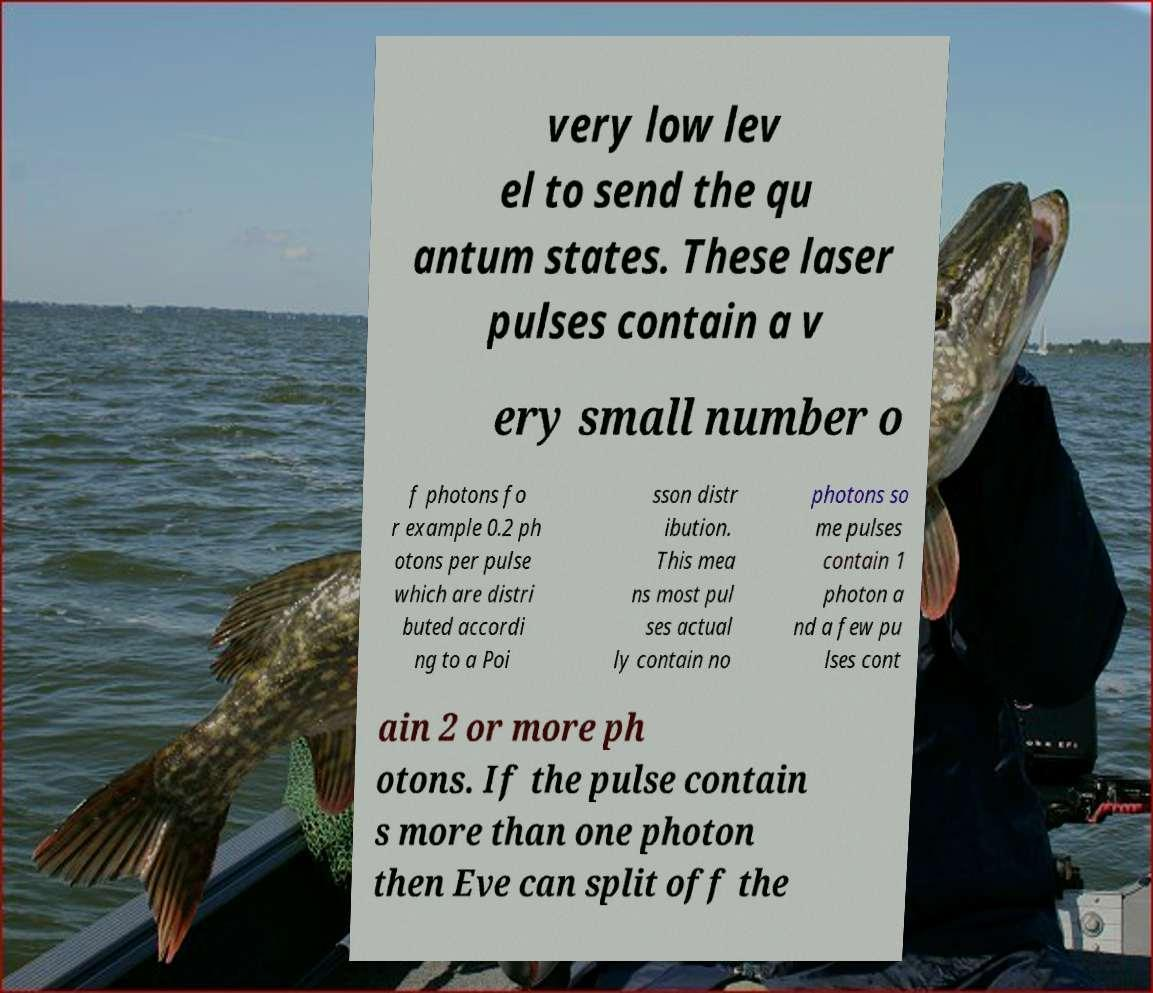There's text embedded in this image that I need extracted. Can you transcribe it verbatim? very low lev el to send the qu antum states. These laser pulses contain a v ery small number o f photons fo r example 0.2 ph otons per pulse which are distri buted accordi ng to a Poi sson distr ibution. This mea ns most pul ses actual ly contain no photons so me pulses contain 1 photon a nd a few pu lses cont ain 2 or more ph otons. If the pulse contain s more than one photon then Eve can split off the 